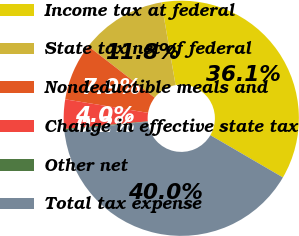Convert chart to OTSL. <chart><loc_0><loc_0><loc_500><loc_500><pie_chart><fcel>Income tax at federal<fcel>State tax net of federal<fcel>Nondeductible meals and<fcel>Change in effective state tax<fcel>Other net<fcel>Total tax expense<nl><fcel>36.1%<fcel>11.8%<fcel>7.92%<fcel>4.04%<fcel>0.17%<fcel>39.98%<nl></chart> 